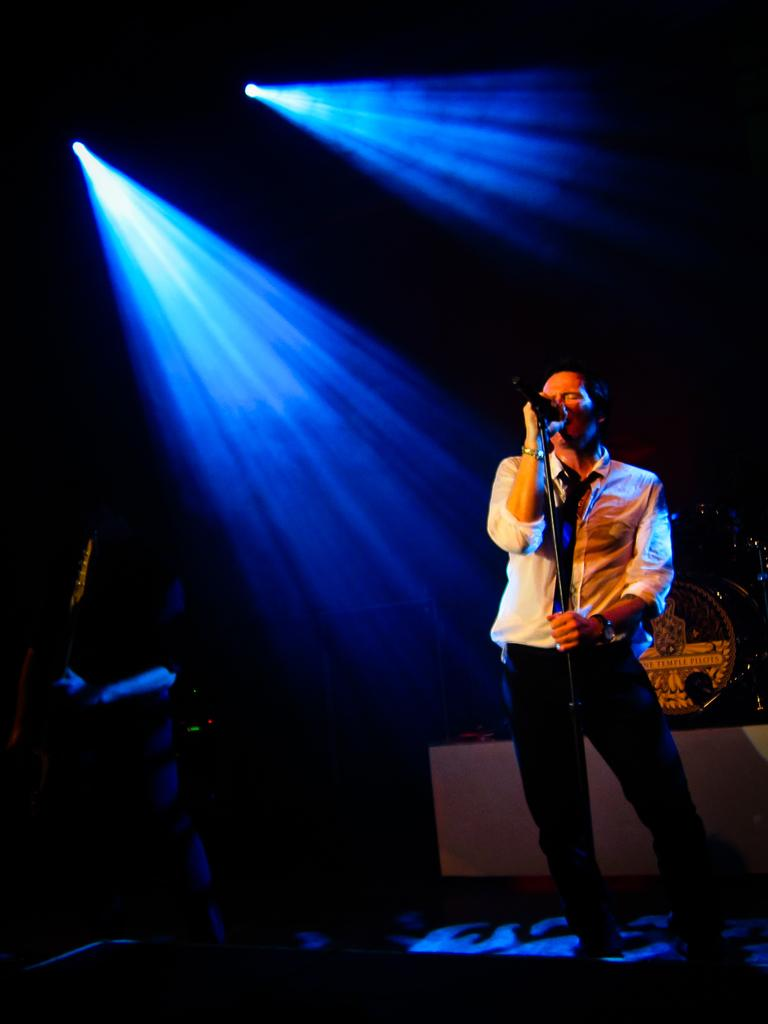What is the main subject of the image? The main subject of the image is a man. What is the man doing in the image? The man is standing and singing a song. Can you describe the background of the image? The background of the image is dark, and there are objects visible. How is the man being illuminated in the image? There are two lights focusing on the man. What type of wound can be seen on the man's arm in the image? There is no wound visible on the man's arm in the image. What kind of breakfast is the man eating in the image? The image does not show the man eating breakfast; he is singing a song. 